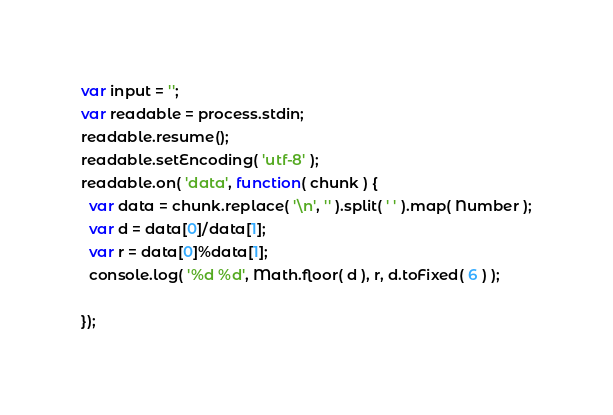<code> <loc_0><loc_0><loc_500><loc_500><_JavaScript_>var input = '';
var readable = process.stdin;
readable.resume();
readable.setEncoding( 'utf-8' );
readable.on( 'data', function( chunk ) {
  var data = chunk.replace( '\n', '' ).split( ' ' ).map( Number );
  var d = data[0]/data[1];
  var r = data[0]%data[1];
  console.log( '%d %d', Math.floor( d ), r, d.toFixed( 6 ) );

});</code> 